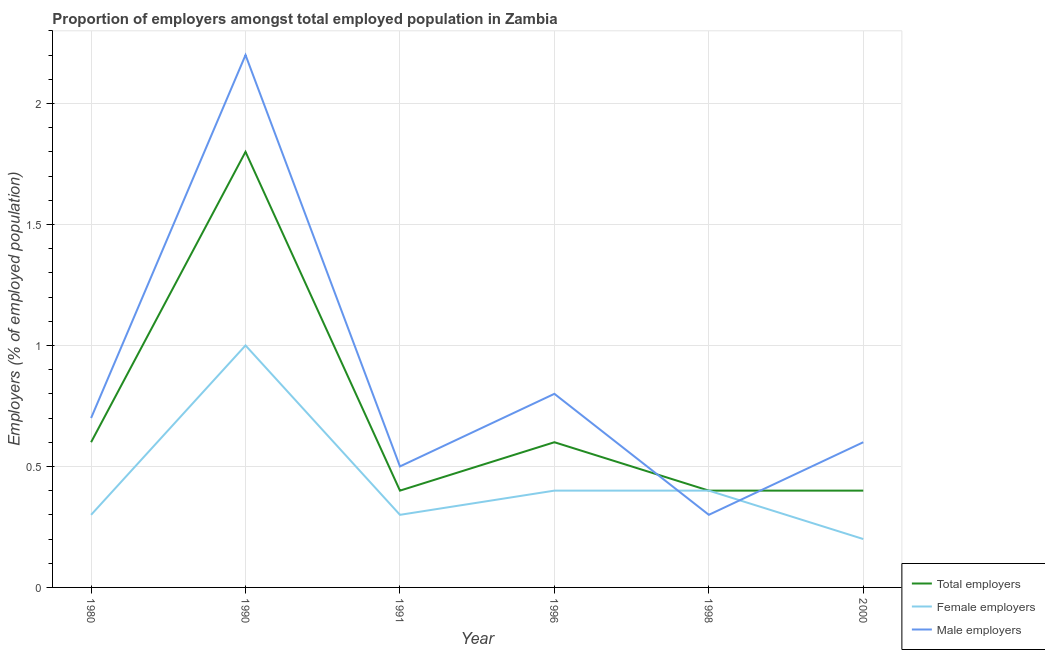Does the line corresponding to percentage of male employers intersect with the line corresponding to percentage of female employers?
Keep it short and to the point. Yes. Is the number of lines equal to the number of legend labels?
Ensure brevity in your answer.  Yes. What is the percentage of male employers in 1996?
Provide a short and direct response. 0.8. Across all years, what is the maximum percentage of male employers?
Ensure brevity in your answer.  2.2. Across all years, what is the minimum percentage of female employers?
Make the answer very short. 0.2. In which year was the percentage of total employers minimum?
Offer a terse response. 1991. What is the total percentage of total employers in the graph?
Give a very brief answer. 4.2. What is the difference between the percentage of male employers in 1996 and that in 2000?
Provide a succinct answer. 0.2. What is the difference between the percentage of male employers in 1996 and the percentage of female employers in 1998?
Provide a succinct answer. 0.4. What is the average percentage of female employers per year?
Offer a very short reply. 0.43. In the year 1990, what is the difference between the percentage of female employers and percentage of total employers?
Provide a short and direct response. -0.8. In how many years, is the percentage of male employers greater than 1.1 %?
Provide a short and direct response. 1. What is the ratio of the percentage of male employers in 1991 to that in 1996?
Offer a very short reply. 0.62. What is the difference between the highest and the second highest percentage of male employers?
Keep it short and to the point. 1.4. What is the difference between the highest and the lowest percentage of male employers?
Give a very brief answer. 1.9. In how many years, is the percentage of female employers greater than the average percentage of female employers taken over all years?
Offer a very short reply. 1. Does the percentage of female employers monotonically increase over the years?
Make the answer very short. No. Is the percentage of male employers strictly greater than the percentage of female employers over the years?
Offer a very short reply. No. Is the percentage of total employers strictly less than the percentage of male employers over the years?
Your answer should be compact. No. Are the values on the major ticks of Y-axis written in scientific E-notation?
Give a very brief answer. No. Does the graph contain grids?
Provide a short and direct response. Yes. Where does the legend appear in the graph?
Offer a very short reply. Bottom right. What is the title of the graph?
Ensure brevity in your answer.  Proportion of employers amongst total employed population in Zambia. What is the label or title of the X-axis?
Your answer should be compact. Year. What is the label or title of the Y-axis?
Offer a terse response. Employers (% of employed population). What is the Employers (% of employed population) in Total employers in 1980?
Ensure brevity in your answer.  0.6. What is the Employers (% of employed population) in Female employers in 1980?
Your answer should be compact. 0.3. What is the Employers (% of employed population) in Male employers in 1980?
Your response must be concise. 0.7. What is the Employers (% of employed population) of Total employers in 1990?
Make the answer very short. 1.8. What is the Employers (% of employed population) of Male employers in 1990?
Your response must be concise. 2.2. What is the Employers (% of employed population) of Total employers in 1991?
Provide a succinct answer. 0.4. What is the Employers (% of employed population) of Female employers in 1991?
Offer a very short reply. 0.3. What is the Employers (% of employed population) in Total employers in 1996?
Your response must be concise. 0.6. What is the Employers (% of employed population) in Female employers in 1996?
Keep it short and to the point. 0.4. What is the Employers (% of employed population) of Male employers in 1996?
Ensure brevity in your answer.  0.8. What is the Employers (% of employed population) of Total employers in 1998?
Offer a terse response. 0.4. What is the Employers (% of employed population) in Female employers in 1998?
Your answer should be compact. 0.4. What is the Employers (% of employed population) of Male employers in 1998?
Give a very brief answer. 0.3. What is the Employers (% of employed population) in Total employers in 2000?
Offer a very short reply. 0.4. What is the Employers (% of employed population) in Female employers in 2000?
Offer a very short reply. 0.2. What is the Employers (% of employed population) of Male employers in 2000?
Offer a terse response. 0.6. Across all years, what is the maximum Employers (% of employed population) in Total employers?
Your answer should be very brief. 1.8. Across all years, what is the maximum Employers (% of employed population) of Male employers?
Provide a succinct answer. 2.2. Across all years, what is the minimum Employers (% of employed population) in Total employers?
Your response must be concise. 0.4. Across all years, what is the minimum Employers (% of employed population) of Female employers?
Give a very brief answer. 0.2. Across all years, what is the minimum Employers (% of employed population) in Male employers?
Make the answer very short. 0.3. What is the total Employers (% of employed population) of Total employers in the graph?
Keep it short and to the point. 4.2. What is the total Employers (% of employed population) in Female employers in the graph?
Make the answer very short. 2.6. What is the total Employers (% of employed population) of Male employers in the graph?
Offer a terse response. 5.1. What is the difference between the Employers (% of employed population) of Total employers in 1980 and that in 1990?
Provide a succinct answer. -1.2. What is the difference between the Employers (% of employed population) of Female employers in 1980 and that in 1990?
Offer a very short reply. -0.7. What is the difference between the Employers (% of employed population) in Male employers in 1980 and that in 1990?
Your response must be concise. -1.5. What is the difference between the Employers (% of employed population) of Total employers in 1980 and that in 1991?
Your answer should be compact. 0.2. What is the difference between the Employers (% of employed population) in Female employers in 1980 and that in 1991?
Your answer should be compact. 0. What is the difference between the Employers (% of employed population) in Male employers in 1980 and that in 1991?
Keep it short and to the point. 0.2. What is the difference between the Employers (% of employed population) of Male employers in 1980 and that in 1996?
Your answer should be very brief. -0.1. What is the difference between the Employers (% of employed population) of Total employers in 1980 and that in 1998?
Ensure brevity in your answer.  0.2. What is the difference between the Employers (% of employed population) of Female employers in 1980 and that in 1998?
Your response must be concise. -0.1. What is the difference between the Employers (% of employed population) of Male employers in 1980 and that in 1998?
Your response must be concise. 0.4. What is the difference between the Employers (% of employed population) of Female employers in 1980 and that in 2000?
Offer a very short reply. 0.1. What is the difference between the Employers (% of employed population) of Total employers in 1990 and that in 1991?
Offer a terse response. 1.4. What is the difference between the Employers (% of employed population) of Female employers in 1990 and that in 1991?
Provide a succinct answer. 0.7. What is the difference between the Employers (% of employed population) of Total employers in 1990 and that in 1996?
Offer a very short reply. 1.2. What is the difference between the Employers (% of employed population) in Female employers in 1990 and that in 1996?
Your answer should be very brief. 0.6. What is the difference between the Employers (% of employed population) in Total employers in 1990 and that in 1998?
Give a very brief answer. 1.4. What is the difference between the Employers (% of employed population) of Male employers in 1990 and that in 1998?
Offer a terse response. 1.9. What is the difference between the Employers (% of employed population) in Total employers in 1990 and that in 2000?
Provide a short and direct response. 1.4. What is the difference between the Employers (% of employed population) of Female employers in 1990 and that in 2000?
Give a very brief answer. 0.8. What is the difference between the Employers (% of employed population) of Female employers in 1991 and that in 1996?
Keep it short and to the point. -0.1. What is the difference between the Employers (% of employed population) in Male employers in 1991 and that in 1996?
Keep it short and to the point. -0.3. What is the difference between the Employers (% of employed population) of Total employers in 1991 and that in 1998?
Give a very brief answer. 0. What is the difference between the Employers (% of employed population) in Total employers in 1991 and that in 2000?
Your answer should be compact. 0. What is the difference between the Employers (% of employed population) of Male employers in 1991 and that in 2000?
Ensure brevity in your answer.  -0.1. What is the difference between the Employers (% of employed population) in Total employers in 1996 and that in 1998?
Ensure brevity in your answer.  0.2. What is the difference between the Employers (% of employed population) of Male employers in 1996 and that in 1998?
Keep it short and to the point. 0.5. What is the difference between the Employers (% of employed population) of Total employers in 1996 and that in 2000?
Ensure brevity in your answer.  0.2. What is the difference between the Employers (% of employed population) in Female employers in 1996 and that in 2000?
Offer a very short reply. 0.2. What is the difference between the Employers (% of employed population) of Male employers in 1998 and that in 2000?
Your answer should be very brief. -0.3. What is the difference between the Employers (% of employed population) of Total employers in 1980 and the Employers (% of employed population) of Female employers in 1990?
Your response must be concise. -0.4. What is the difference between the Employers (% of employed population) in Female employers in 1980 and the Employers (% of employed population) in Male employers in 1990?
Offer a terse response. -1.9. What is the difference between the Employers (% of employed population) of Total employers in 1980 and the Employers (% of employed population) of Female employers in 1991?
Ensure brevity in your answer.  0.3. What is the difference between the Employers (% of employed population) of Female employers in 1980 and the Employers (% of employed population) of Male employers in 1991?
Your response must be concise. -0.2. What is the difference between the Employers (% of employed population) of Female employers in 1980 and the Employers (% of employed population) of Male employers in 1998?
Make the answer very short. 0. What is the difference between the Employers (% of employed population) of Female employers in 1980 and the Employers (% of employed population) of Male employers in 2000?
Provide a short and direct response. -0.3. What is the difference between the Employers (% of employed population) of Female employers in 1990 and the Employers (% of employed population) of Male employers in 1991?
Keep it short and to the point. 0.5. What is the difference between the Employers (% of employed population) of Total employers in 1990 and the Employers (% of employed population) of Female employers in 1996?
Your answer should be very brief. 1.4. What is the difference between the Employers (% of employed population) in Total employers in 1990 and the Employers (% of employed population) in Male employers in 1996?
Ensure brevity in your answer.  1. What is the difference between the Employers (% of employed population) of Female employers in 1990 and the Employers (% of employed population) of Male employers in 1996?
Ensure brevity in your answer.  0.2. What is the difference between the Employers (% of employed population) in Total employers in 1990 and the Employers (% of employed population) in Female employers in 1998?
Your answer should be very brief. 1.4. What is the difference between the Employers (% of employed population) in Female employers in 1990 and the Employers (% of employed population) in Male employers in 2000?
Your answer should be very brief. 0.4. What is the difference between the Employers (% of employed population) in Total employers in 1991 and the Employers (% of employed population) in Female employers in 1996?
Your answer should be compact. 0. What is the difference between the Employers (% of employed population) of Female employers in 1991 and the Employers (% of employed population) of Male employers in 1996?
Offer a very short reply. -0.5. What is the difference between the Employers (% of employed population) of Total employers in 1991 and the Employers (% of employed population) of Male employers in 1998?
Ensure brevity in your answer.  0.1. What is the difference between the Employers (% of employed population) in Total employers in 1991 and the Employers (% of employed population) in Male employers in 2000?
Ensure brevity in your answer.  -0.2. What is the difference between the Employers (% of employed population) in Female employers in 1991 and the Employers (% of employed population) in Male employers in 2000?
Provide a short and direct response. -0.3. What is the difference between the Employers (% of employed population) in Total employers in 1996 and the Employers (% of employed population) in Female employers in 1998?
Your answer should be very brief. 0.2. What is the difference between the Employers (% of employed population) in Female employers in 1996 and the Employers (% of employed population) in Male employers in 2000?
Provide a short and direct response. -0.2. What is the difference between the Employers (% of employed population) in Total employers in 1998 and the Employers (% of employed population) in Male employers in 2000?
Keep it short and to the point. -0.2. What is the average Employers (% of employed population) of Female employers per year?
Provide a succinct answer. 0.43. In the year 1980, what is the difference between the Employers (% of employed population) of Total employers and Employers (% of employed population) of Female employers?
Ensure brevity in your answer.  0.3. In the year 1990, what is the difference between the Employers (% of employed population) in Total employers and Employers (% of employed population) in Male employers?
Provide a short and direct response. -0.4. In the year 1991, what is the difference between the Employers (% of employed population) in Female employers and Employers (% of employed population) in Male employers?
Give a very brief answer. -0.2. In the year 1996, what is the difference between the Employers (% of employed population) of Total employers and Employers (% of employed population) of Male employers?
Offer a very short reply. -0.2. In the year 1998, what is the difference between the Employers (% of employed population) in Total employers and Employers (% of employed population) in Female employers?
Offer a very short reply. 0. What is the ratio of the Employers (% of employed population) in Male employers in 1980 to that in 1990?
Ensure brevity in your answer.  0.32. What is the ratio of the Employers (% of employed population) in Total employers in 1980 to that in 1991?
Give a very brief answer. 1.5. What is the ratio of the Employers (% of employed population) in Female employers in 1980 to that in 1991?
Offer a very short reply. 1. What is the ratio of the Employers (% of employed population) of Female employers in 1980 to that in 1998?
Provide a short and direct response. 0.75. What is the ratio of the Employers (% of employed population) in Male employers in 1980 to that in 1998?
Provide a short and direct response. 2.33. What is the ratio of the Employers (% of employed population) of Total employers in 1980 to that in 2000?
Your answer should be compact. 1.5. What is the ratio of the Employers (% of employed population) of Male employers in 1980 to that in 2000?
Your response must be concise. 1.17. What is the ratio of the Employers (% of employed population) in Total employers in 1990 to that in 1991?
Give a very brief answer. 4.5. What is the ratio of the Employers (% of employed population) in Male employers in 1990 to that in 1991?
Offer a very short reply. 4.4. What is the ratio of the Employers (% of employed population) in Total employers in 1990 to that in 1996?
Provide a short and direct response. 3. What is the ratio of the Employers (% of employed population) in Female employers in 1990 to that in 1996?
Ensure brevity in your answer.  2.5. What is the ratio of the Employers (% of employed population) of Male employers in 1990 to that in 1996?
Ensure brevity in your answer.  2.75. What is the ratio of the Employers (% of employed population) of Female employers in 1990 to that in 1998?
Keep it short and to the point. 2.5. What is the ratio of the Employers (% of employed population) in Male employers in 1990 to that in 1998?
Your response must be concise. 7.33. What is the ratio of the Employers (% of employed population) in Total employers in 1990 to that in 2000?
Your response must be concise. 4.5. What is the ratio of the Employers (% of employed population) of Male employers in 1990 to that in 2000?
Ensure brevity in your answer.  3.67. What is the ratio of the Employers (% of employed population) in Total employers in 1991 to that in 1996?
Give a very brief answer. 0.67. What is the ratio of the Employers (% of employed population) of Female employers in 1991 to that in 1996?
Keep it short and to the point. 0.75. What is the ratio of the Employers (% of employed population) of Male employers in 1991 to that in 1996?
Your response must be concise. 0.62. What is the ratio of the Employers (% of employed population) of Female employers in 1991 to that in 2000?
Offer a terse response. 1.5. What is the ratio of the Employers (% of employed population) in Female employers in 1996 to that in 1998?
Your answer should be compact. 1. What is the ratio of the Employers (% of employed population) of Male employers in 1996 to that in 1998?
Provide a short and direct response. 2.67. What is the ratio of the Employers (% of employed population) of Total employers in 1998 to that in 2000?
Ensure brevity in your answer.  1. What is the ratio of the Employers (% of employed population) of Female employers in 1998 to that in 2000?
Your answer should be very brief. 2. What is the difference between the highest and the second highest Employers (% of employed population) in Total employers?
Keep it short and to the point. 1.2. What is the difference between the highest and the second highest Employers (% of employed population) in Male employers?
Offer a terse response. 1.4. What is the difference between the highest and the lowest Employers (% of employed population) in Female employers?
Keep it short and to the point. 0.8. What is the difference between the highest and the lowest Employers (% of employed population) of Male employers?
Provide a succinct answer. 1.9. 